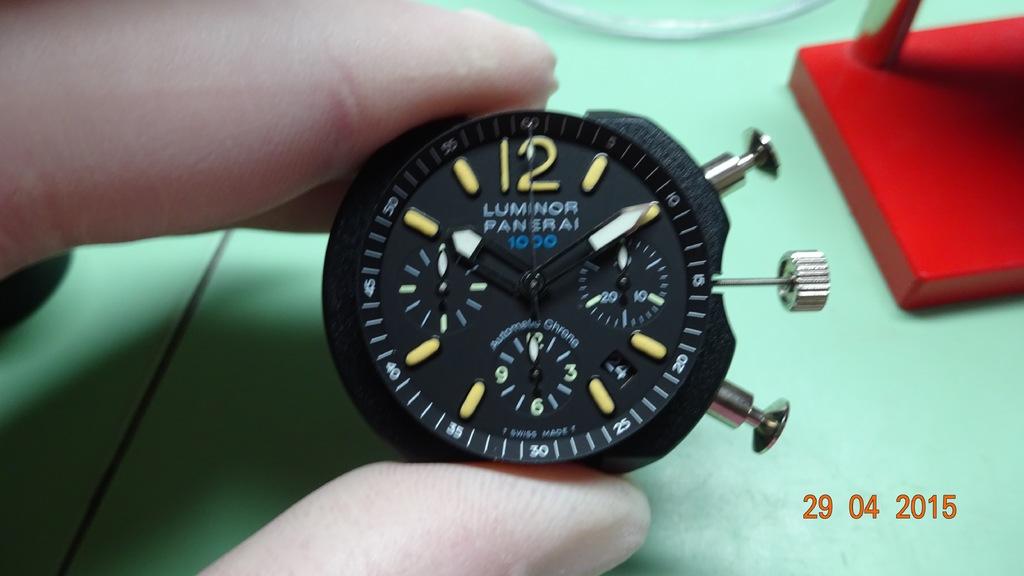What is the number on the watch?
Your answer should be compact. 12. What number does the seconds hand point too on the watch face?
Provide a short and direct response. 12. 